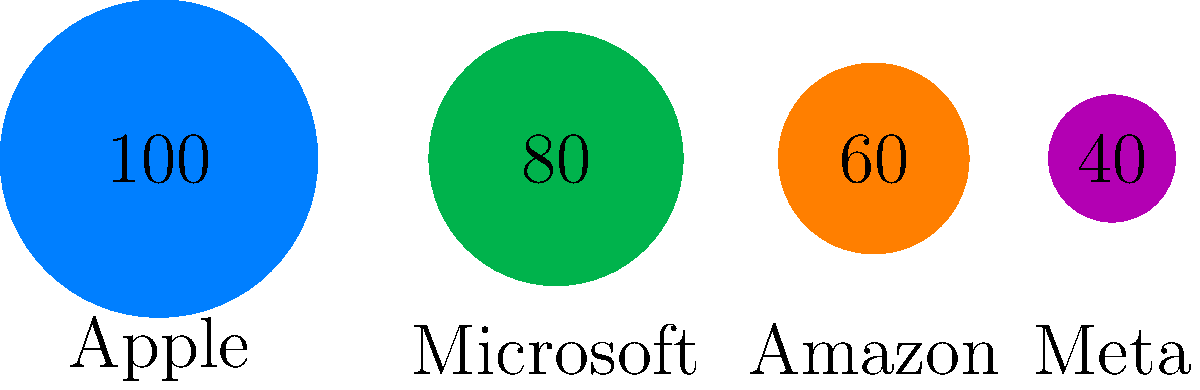Based on the proportional circles representing market capitalization of tech companies, what is the approximate ratio of Apple's market cap to Meta's market cap? To determine the ratio of Apple's market cap to Meta's, we need to follow these steps:

1. Observe that the circles represent market capitalization, with larger circles indicating higher market cap.

2. The numbers inside the circles represent the relative size of each company's market cap.

3. Apple's circle has a value of 100, while Meta's circle has a value of 40.

4. To calculate the ratio, we divide Apple's value by Meta's value:

   $$\frac{\text{Apple's value}}{\text{Meta's value}} = \frac{100}{40} = 2.5$$

5. This means Apple's market cap is approximately 2.5 times larger than Meta's.

6. To express this as a ratio, we can write it as 2.5:1 or 5:2.

Therefore, the approximate ratio of Apple's market cap to Meta's market cap is 2.5:1 or 5:2.
Answer: 2.5:1 